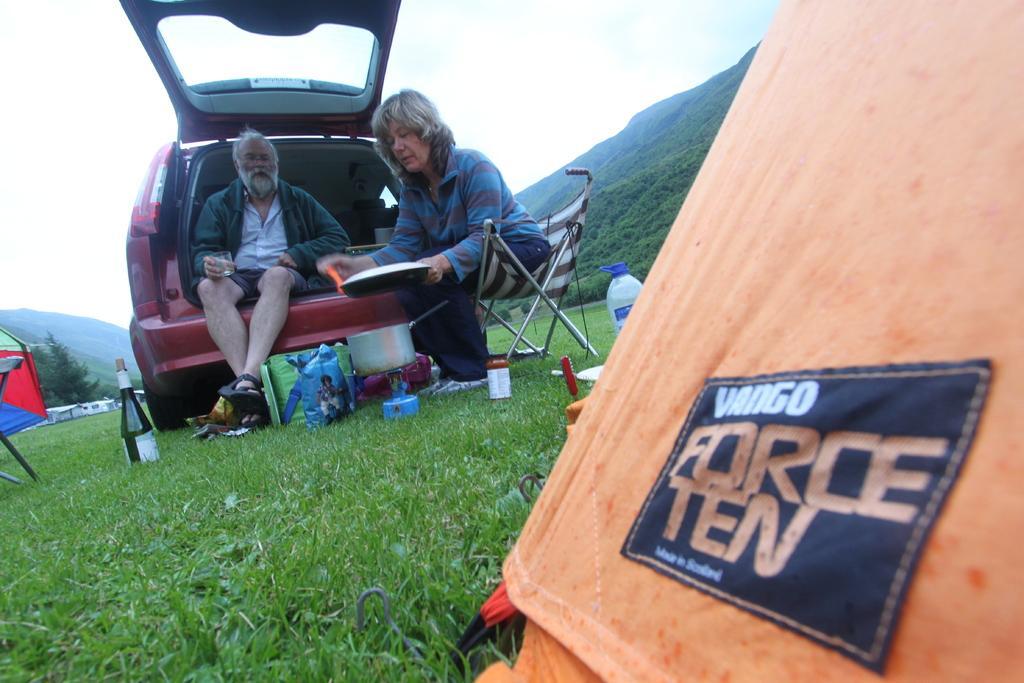Can you describe this image briefly? In this picture we can see a man sitting on car and beside to his woman sitting on chair holding bowl in her hand and in front of them we have bottle, bag on grass and in the background we can see mountains, sky. 